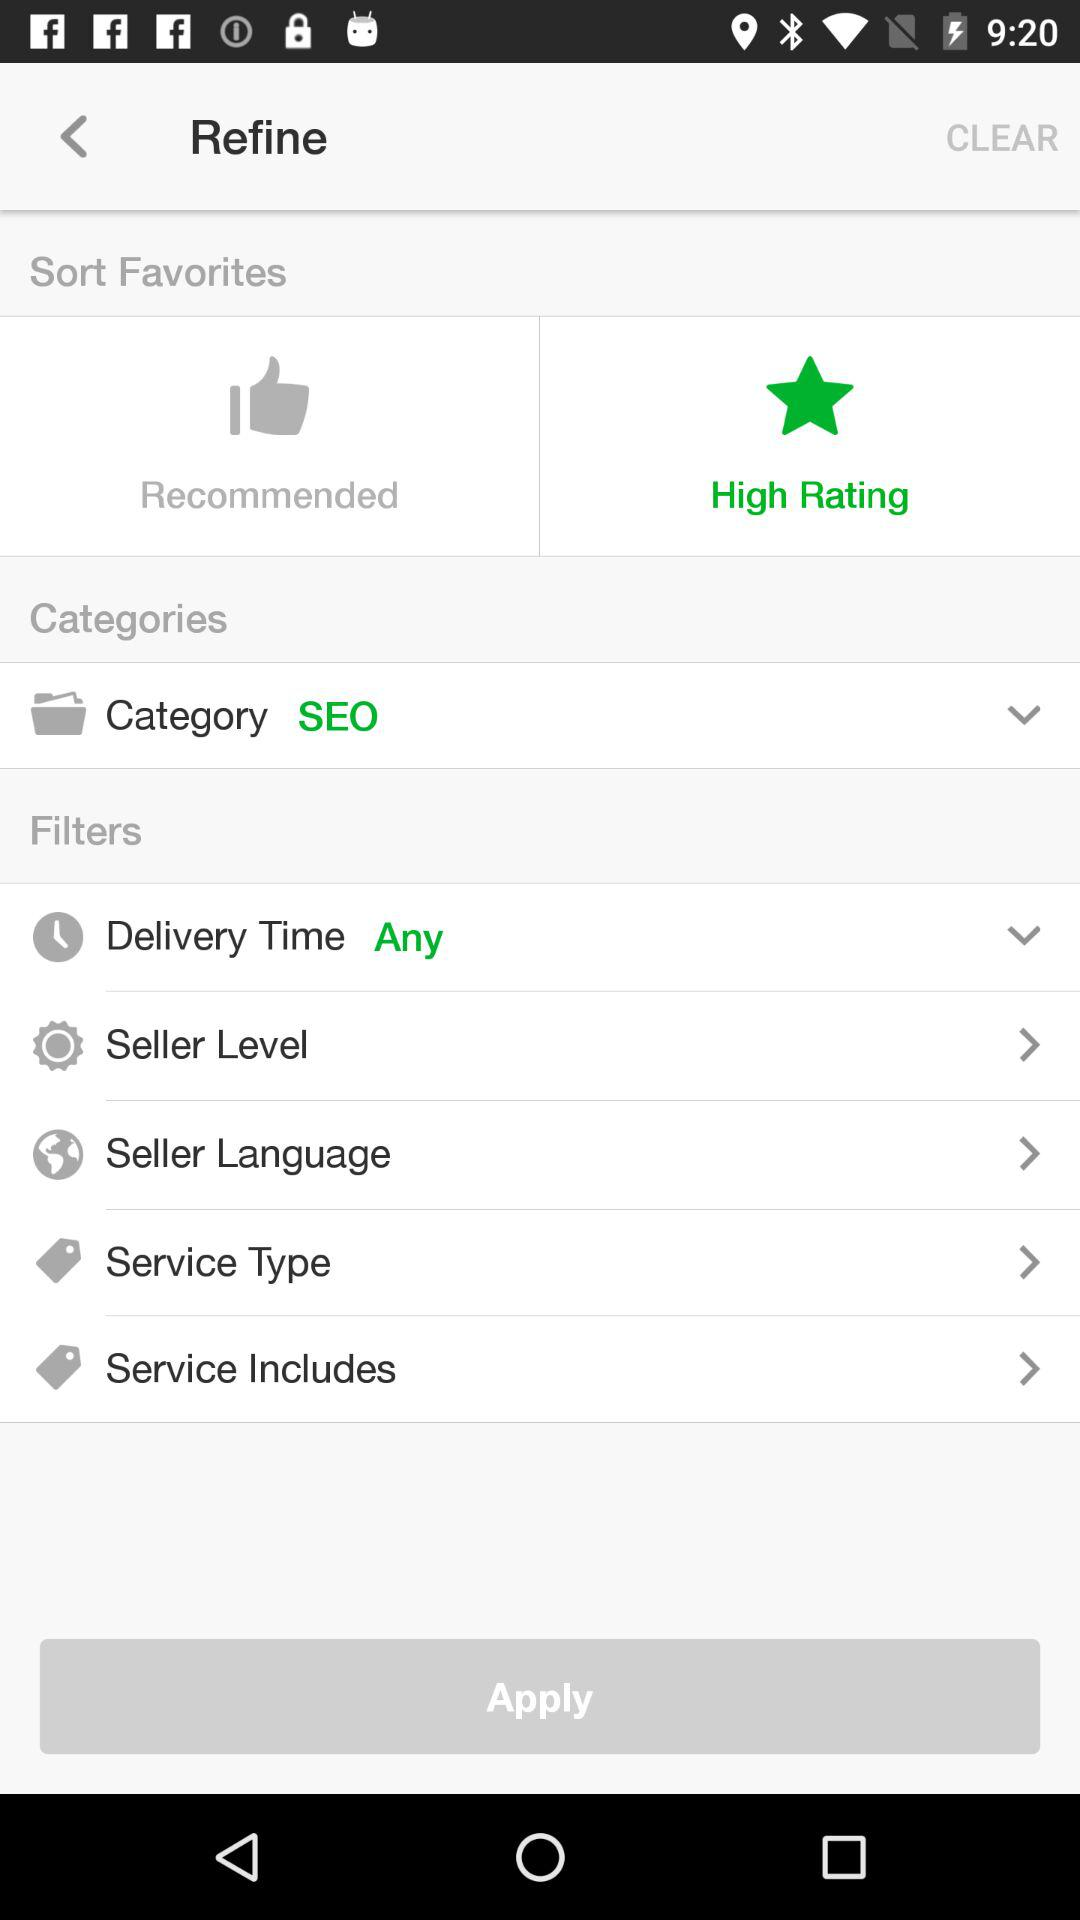What option is selected in "Delivery Time"? The selected option is "Any". 